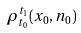<formula> <loc_0><loc_0><loc_500><loc_500>\rho _ { t _ { 0 } } ^ { t _ { 1 } } ( x _ { 0 } , n _ { 0 } )</formula> 